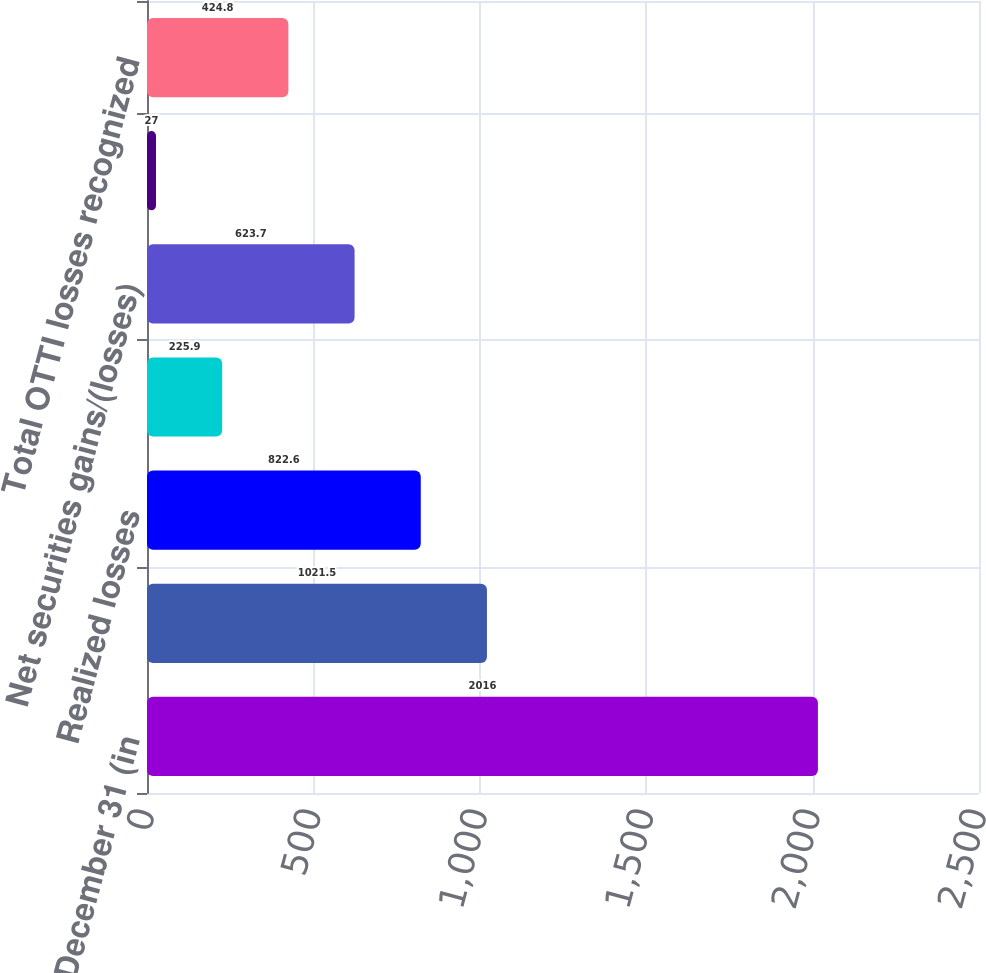Convert chart. <chart><loc_0><loc_0><loc_500><loc_500><bar_chart><fcel>Year ended December 31 (in<fcel>Realized gains<fcel>Realized losses<fcel>OTTI losses (a)<fcel>Net securities gains/(losses)<fcel>Securities the Firm intends to<fcel>Total OTTI losses recognized<nl><fcel>2016<fcel>1021.5<fcel>822.6<fcel>225.9<fcel>623.7<fcel>27<fcel>424.8<nl></chart> 